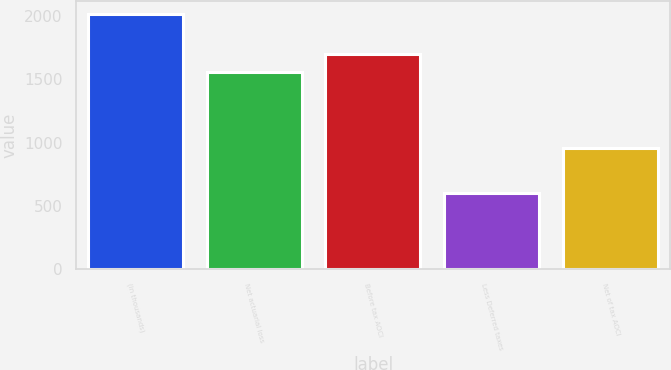Convert chart to OTSL. <chart><loc_0><loc_0><loc_500><loc_500><bar_chart><fcel>(in thousands)<fcel>Net actuarial loss<fcel>Before tax AOCI<fcel>Less Deferred taxes<fcel>Net of tax AOCI<nl><fcel>2013<fcel>1557<fcel>1697.8<fcel>605<fcel>961<nl></chart> 